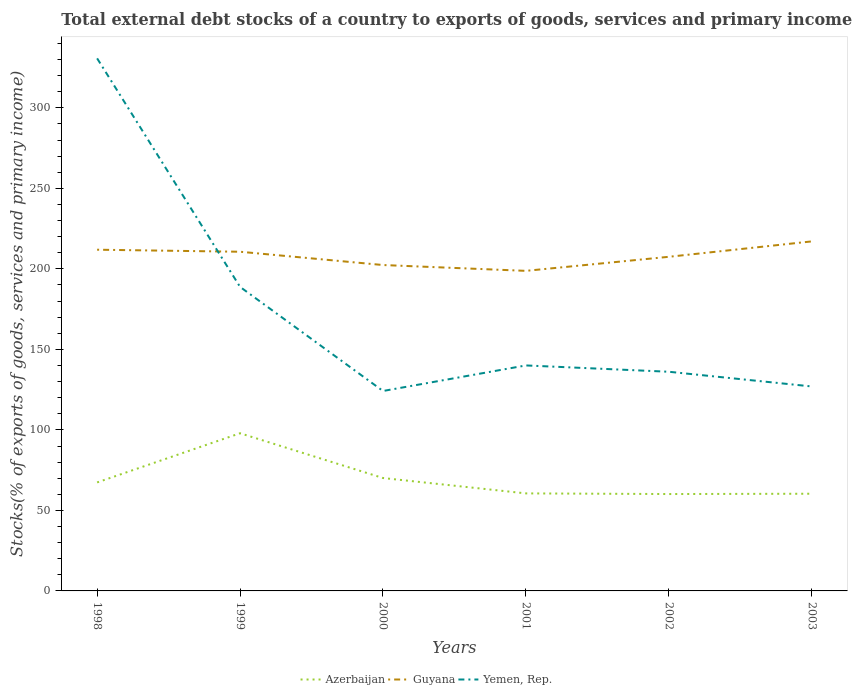Does the line corresponding to Yemen, Rep. intersect with the line corresponding to Guyana?
Keep it short and to the point. Yes. Is the number of lines equal to the number of legend labels?
Provide a succinct answer. Yes. Across all years, what is the maximum total debt stocks in Guyana?
Make the answer very short. 198.77. In which year was the total debt stocks in Azerbaijan maximum?
Your answer should be compact. 2002. What is the total total debt stocks in Yemen, Rep. in the graph?
Give a very brief answer. 194.63. What is the difference between the highest and the second highest total debt stocks in Yemen, Rep.?
Offer a terse response. 206.57. Is the total debt stocks in Guyana strictly greater than the total debt stocks in Yemen, Rep. over the years?
Provide a short and direct response. No. How many lines are there?
Provide a succinct answer. 3. Are the values on the major ticks of Y-axis written in scientific E-notation?
Your answer should be very brief. No. Where does the legend appear in the graph?
Ensure brevity in your answer.  Bottom center. How many legend labels are there?
Ensure brevity in your answer.  3. How are the legend labels stacked?
Your response must be concise. Horizontal. What is the title of the graph?
Offer a very short reply. Total external debt stocks of a country to exports of goods, services and primary income. What is the label or title of the Y-axis?
Give a very brief answer. Stocks(% of exports of goods, services and primary income). What is the Stocks(% of exports of goods, services and primary income) in Azerbaijan in 1998?
Give a very brief answer. 67.38. What is the Stocks(% of exports of goods, services and primary income) in Guyana in 1998?
Provide a succinct answer. 211.9. What is the Stocks(% of exports of goods, services and primary income) in Yemen, Rep. in 1998?
Make the answer very short. 330.74. What is the Stocks(% of exports of goods, services and primary income) in Azerbaijan in 1999?
Give a very brief answer. 97.92. What is the Stocks(% of exports of goods, services and primary income) of Guyana in 1999?
Offer a very short reply. 210.64. What is the Stocks(% of exports of goods, services and primary income) of Yemen, Rep. in 1999?
Ensure brevity in your answer.  188.81. What is the Stocks(% of exports of goods, services and primary income) in Azerbaijan in 2000?
Ensure brevity in your answer.  70.11. What is the Stocks(% of exports of goods, services and primary income) in Guyana in 2000?
Your answer should be compact. 202.39. What is the Stocks(% of exports of goods, services and primary income) in Yemen, Rep. in 2000?
Make the answer very short. 124.16. What is the Stocks(% of exports of goods, services and primary income) in Azerbaijan in 2001?
Your response must be concise. 60.57. What is the Stocks(% of exports of goods, services and primary income) in Guyana in 2001?
Offer a terse response. 198.77. What is the Stocks(% of exports of goods, services and primary income) in Yemen, Rep. in 2001?
Offer a very short reply. 140.04. What is the Stocks(% of exports of goods, services and primary income) of Azerbaijan in 2002?
Keep it short and to the point. 60.16. What is the Stocks(% of exports of goods, services and primary income) in Guyana in 2002?
Your answer should be compact. 207.5. What is the Stocks(% of exports of goods, services and primary income) of Yemen, Rep. in 2002?
Your answer should be compact. 136.11. What is the Stocks(% of exports of goods, services and primary income) of Azerbaijan in 2003?
Your answer should be very brief. 60.36. What is the Stocks(% of exports of goods, services and primary income) of Guyana in 2003?
Offer a very short reply. 217.07. What is the Stocks(% of exports of goods, services and primary income) of Yemen, Rep. in 2003?
Keep it short and to the point. 126.97. Across all years, what is the maximum Stocks(% of exports of goods, services and primary income) of Azerbaijan?
Give a very brief answer. 97.92. Across all years, what is the maximum Stocks(% of exports of goods, services and primary income) in Guyana?
Make the answer very short. 217.07. Across all years, what is the maximum Stocks(% of exports of goods, services and primary income) of Yemen, Rep.?
Provide a succinct answer. 330.74. Across all years, what is the minimum Stocks(% of exports of goods, services and primary income) of Azerbaijan?
Ensure brevity in your answer.  60.16. Across all years, what is the minimum Stocks(% of exports of goods, services and primary income) in Guyana?
Give a very brief answer. 198.77. Across all years, what is the minimum Stocks(% of exports of goods, services and primary income) of Yemen, Rep.?
Your response must be concise. 124.16. What is the total Stocks(% of exports of goods, services and primary income) of Azerbaijan in the graph?
Keep it short and to the point. 416.51. What is the total Stocks(% of exports of goods, services and primary income) in Guyana in the graph?
Offer a very short reply. 1248.27. What is the total Stocks(% of exports of goods, services and primary income) in Yemen, Rep. in the graph?
Offer a very short reply. 1046.83. What is the difference between the Stocks(% of exports of goods, services and primary income) of Azerbaijan in 1998 and that in 1999?
Your response must be concise. -30.53. What is the difference between the Stocks(% of exports of goods, services and primary income) of Guyana in 1998 and that in 1999?
Offer a very short reply. 1.26. What is the difference between the Stocks(% of exports of goods, services and primary income) of Yemen, Rep. in 1998 and that in 1999?
Your response must be concise. 141.92. What is the difference between the Stocks(% of exports of goods, services and primary income) of Azerbaijan in 1998 and that in 2000?
Provide a succinct answer. -2.73. What is the difference between the Stocks(% of exports of goods, services and primary income) in Guyana in 1998 and that in 2000?
Your answer should be compact. 9.51. What is the difference between the Stocks(% of exports of goods, services and primary income) of Yemen, Rep. in 1998 and that in 2000?
Your answer should be compact. 206.57. What is the difference between the Stocks(% of exports of goods, services and primary income) of Azerbaijan in 1998 and that in 2001?
Offer a very short reply. 6.81. What is the difference between the Stocks(% of exports of goods, services and primary income) of Guyana in 1998 and that in 2001?
Offer a terse response. 13.13. What is the difference between the Stocks(% of exports of goods, services and primary income) of Yemen, Rep. in 1998 and that in 2001?
Keep it short and to the point. 190.7. What is the difference between the Stocks(% of exports of goods, services and primary income) of Azerbaijan in 1998 and that in 2002?
Your response must be concise. 7.22. What is the difference between the Stocks(% of exports of goods, services and primary income) in Guyana in 1998 and that in 2002?
Your answer should be very brief. 4.4. What is the difference between the Stocks(% of exports of goods, services and primary income) of Yemen, Rep. in 1998 and that in 2002?
Your response must be concise. 194.63. What is the difference between the Stocks(% of exports of goods, services and primary income) in Azerbaijan in 1998 and that in 2003?
Offer a terse response. 7.02. What is the difference between the Stocks(% of exports of goods, services and primary income) in Guyana in 1998 and that in 2003?
Provide a succinct answer. -5.17. What is the difference between the Stocks(% of exports of goods, services and primary income) in Yemen, Rep. in 1998 and that in 2003?
Make the answer very short. 203.76. What is the difference between the Stocks(% of exports of goods, services and primary income) in Azerbaijan in 1999 and that in 2000?
Provide a succinct answer. 27.8. What is the difference between the Stocks(% of exports of goods, services and primary income) in Guyana in 1999 and that in 2000?
Offer a terse response. 8.25. What is the difference between the Stocks(% of exports of goods, services and primary income) of Yemen, Rep. in 1999 and that in 2000?
Provide a succinct answer. 64.65. What is the difference between the Stocks(% of exports of goods, services and primary income) of Azerbaijan in 1999 and that in 2001?
Offer a very short reply. 37.35. What is the difference between the Stocks(% of exports of goods, services and primary income) in Guyana in 1999 and that in 2001?
Your answer should be compact. 11.87. What is the difference between the Stocks(% of exports of goods, services and primary income) in Yemen, Rep. in 1999 and that in 2001?
Make the answer very short. 48.77. What is the difference between the Stocks(% of exports of goods, services and primary income) in Azerbaijan in 1999 and that in 2002?
Ensure brevity in your answer.  37.75. What is the difference between the Stocks(% of exports of goods, services and primary income) of Guyana in 1999 and that in 2002?
Make the answer very short. 3.14. What is the difference between the Stocks(% of exports of goods, services and primary income) of Yemen, Rep. in 1999 and that in 2002?
Ensure brevity in your answer.  52.7. What is the difference between the Stocks(% of exports of goods, services and primary income) of Azerbaijan in 1999 and that in 2003?
Your response must be concise. 37.56. What is the difference between the Stocks(% of exports of goods, services and primary income) of Guyana in 1999 and that in 2003?
Your answer should be compact. -6.43. What is the difference between the Stocks(% of exports of goods, services and primary income) of Yemen, Rep. in 1999 and that in 2003?
Provide a succinct answer. 61.84. What is the difference between the Stocks(% of exports of goods, services and primary income) of Azerbaijan in 2000 and that in 2001?
Make the answer very short. 9.54. What is the difference between the Stocks(% of exports of goods, services and primary income) of Guyana in 2000 and that in 2001?
Your answer should be very brief. 3.62. What is the difference between the Stocks(% of exports of goods, services and primary income) in Yemen, Rep. in 2000 and that in 2001?
Your answer should be very brief. -15.87. What is the difference between the Stocks(% of exports of goods, services and primary income) of Azerbaijan in 2000 and that in 2002?
Provide a short and direct response. 9.95. What is the difference between the Stocks(% of exports of goods, services and primary income) in Guyana in 2000 and that in 2002?
Your response must be concise. -5.11. What is the difference between the Stocks(% of exports of goods, services and primary income) in Yemen, Rep. in 2000 and that in 2002?
Your response must be concise. -11.94. What is the difference between the Stocks(% of exports of goods, services and primary income) in Azerbaijan in 2000 and that in 2003?
Give a very brief answer. 9.75. What is the difference between the Stocks(% of exports of goods, services and primary income) in Guyana in 2000 and that in 2003?
Offer a terse response. -14.68. What is the difference between the Stocks(% of exports of goods, services and primary income) of Yemen, Rep. in 2000 and that in 2003?
Ensure brevity in your answer.  -2.81. What is the difference between the Stocks(% of exports of goods, services and primary income) in Azerbaijan in 2001 and that in 2002?
Offer a very short reply. 0.4. What is the difference between the Stocks(% of exports of goods, services and primary income) of Guyana in 2001 and that in 2002?
Keep it short and to the point. -8.73. What is the difference between the Stocks(% of exports of goods, services and primary income) in Yemen, Rep. in 2001 and that in 2002?
Your response must be concise. 3.93. What is the difference between the Stocks(% of exports of goods, services and primary income) in Azerbaijan in 2001 and that in 2003?
Your answer should be compact. 0.21. What is the difference between the Stocks(% of exports of goods, services and primary income) in Guyana in 2001 and that in 2003?
Keep it short and to the point. -18.3. What is the difference between the Stocks(% of exports of goods, services and primary income) in Yemen, Rep. in 2001 and that in 2003?
Your answer should be compact. 13.06. What is the difference between the Stocks(% of exports of goods, services and primary income) of Azerbaijan in 2002 and that in 2003?
Provide a short and direct response. -0.19. What is the difference between the Stocks(% of exports of goods, services and primary income) in Guyana in 2002 and that in 2003?
Keep it short and to the point. -9.57. What is the difference between the Stocks(% of exports of goods, services and primary income) of Yemen, Rep. in 2002 and that in 2003?
Make the answer very short. 9.13. What is the difference between the Stocks(% of exports of goods, services and primary income) in Azerbaijan in 1998 and the Stocks(% of exports of goods, services and primary income) in Guyana in 1999?
Your response must be concise. -143.26. What is the difference between the Stocks(% of exports of goods, services and primary income) in Azerbaijan in 1998 and the Stocks(% of exports of goods, services and primary income) in Yemen, Rep. in 1999?
Your answer should be very brief. -121.43. What is the difference between the Stocks(% of exports of goods, services and primary income) in Guyana in 1998 and the Stocks(% of exports of goods, services and primary income) in Yemen, Rep. in 1999?
Your response must be concise. 23.09. What is the difference between the Stocks(% of exports of goods, services and primary income) in Azerbaijan in 1998 and the Stocks(% of exports of goods, services and primary income) in Guyana in 2000?
Ensure brevity in your answer.  -135.01. What is the difference between the Stocks(% of exports of goods, services and primary income) of Azerbaijan in 1998 and the Stocks(% of exports of goods, services and primary income) of Yemen, Rep. in 2000?
Your response must be concise. -56.78. What is the difference between the Stocks(% of exports of goods, services and primary income) of Guyana in 1998 and the Stocks(% of exports of goods, services and primary income) of Yemen, Rep. in 2000?
Give a very brief answer. 87.74. What is the difference between the Stocks(% of exports of goods, services and primary income) in Azerbaijan in 1998 and the Stocks(% of exports of goods, services and primary income) in Guyana in 2001?
Give a very brief answer. -131.39. What is the difference between the Stocks(% of exports of goods, services and primary income) in Azerbaijan in 1998 and the Stocks(% of exports of goods, services and primary income) in Yemen, Rep. in 2001?
Ensure brevity in your answer.  -72.65. What is the difference between the Stocks(% of exports of goods, services and primary income) of Guyana in 1998 and the Stocks(% of exports of goods, services and primary income) of Yemen, Rep. in 2001?
Your answer should be very brief. 71.86. What is the difference between the Stocks(% of exports of goods, services and primary income) in Azerbaijan in 1998 and the Stocks(% of exports of goods, services and primary income) in Guyana in 2002?
Offer a very short reply. -140.12. What is the difference between the Stocks(% of exports of goods, services and primary income) in Azerbaijan in 1998 and the Stocks(% of exports of goods, services and primary income) in Yemen, Rep. in 2002?
Make the answer very short. -68.72. What is the difference between the Stocks(% of exports of goods, services and primary income) in Guyana in 1998 and the Stocks(% of exports of goods, services and primary income) in Yemen, Rep. in 2002?
Your response must be concise. 75.79. What is the difference between the Stocks(% of exports of goods, services and primary income) of Azerbaijan in 1998 and the Stocks(% of exports of goods, services and primary income) of Guyana in 2003?
Provide a succinct answer. -149.69. What is the difference between the Stocks(% of exports of goods, services and primary income) in Azerbaijan in 1998 and the Stocks(% of exports of goods, services and primary income) in Yemen, Rep. in 2003?
Offer a very short reply. -59.59. What is the difference between the Stocks(% of exports of goods, services and primary income) of Guyana in 1998 and the Stocks(% of exports of goods, services and primary income) of Yemen, Rep. in 2003?
Keep it short and to the point. 84.93. What is the difference between the Stocks(% of exports of goods, services and primary income) in Azerbaijan in 1999 and the Stocks(% of exports of goods, services and primary income) in Guyana in 2000?
Your response must be concise. -104.47. What is the difference between the Stocks(% of exports of goods, services and primary income) in Azerbaijan in 1999 and the Stocks(% of exports of goods, services and primary income) in Yemen, Rep. in 2000?
Offer a terse response. -26.25. What is the difference between the Stocks(% of exports of goods, services and primary income) in Guyana in 1999 and the Stocks(% of exports of goods, services and primary income) in Yemen, Rep. in 2000?
Offer a very short reply. 86.48. What is the difference between the Stocks(% of exports of goods, services and primary income) in Azerbaijan in 1999 and the Stocks(% of exports of goods, services and primary income) in Guyana in 2001?
Offer a very short reply. -100.85. What is the difference between the Stocks(% of exports of goods, services and primary income) of Azerbaijan in 1999 and the Stocks(% of exports of goods, services and primary income) of Yemen, Rep. in 2001?
Provide a succinct answer. -42.12. What is the difference between the Stocks(% of exports of goods, services and primary income) in Guyana in 1999 and the Stocks(% of exports of goods, services and primary income) in Yemen, Rep. in 2001?
Provide a short and direct response. 70.6. What is the difference between the Stocks(% of exports of goods, services and primary income) in Azerbaijan in 1999 and the Stocks(% of exports of goods, services and primary income) in Guyana in 2002?
Make the answer very short. -109.58. What is the difference between the Stocks(% of exports of goods, services and primary income) of Azerbaijan in 1999 and the Stocks(% of exports of goods, services and primary income) of Yemen, Rep. in 2002?
Offer a terse response. -38.19. What is the difference between the Stocks(% of exports of goods, services and primary income) of Guyana in 1999 and the Stocks(% of exports of goods, services and primary income) of Yemen, Rep. in 2002?
Make the answer very short. 74.53. What is the difference between the Stocks(% of exports of goods, services and primary income) in Azerbaijan in 1999 and the Stocks(% of exports of goods, services and primary income) in Guyana in 2003?
Provide a short and direct response. -119.15. What is the difference between the Stocks(% of exports of goods, services and primary income) of Azerbaijan in 1999 and the Stocks(% of exports of goods, services and primary income) of Yemen, Rep. in 2003?
Ensure brevity in your answer.  -29.06. What is the difference between the Stocks(% of exports of goods, services and primary income) in Guyana in 1999 and the Stocks(% of exports of goods, services and primary income) in Yemen, Rep. in 2003?
Your answer should be compact. 83.67. What is the difference between the Stocks(% of exports of goods, services and primary income) of Azerbaijan in 2000 and the Stocks(% of exports of goods, services and primary income) of Guyana in 2001?
Keep it short and to the point. -128.66. What is the difference between the Stocks(% of exports of goods, services and primary income) of Azerbaijan in 2000 and the Stocks(% of exports of goods, services and primary income) of Yemen, Rep. in 2001?
Keep it short and to the point. -69.92. What is the difference between the Stocks(% of exports of goods, services and primary income) in Guyana in 2000 and the Stocks(% of exports of goods, services and primary income) in Yemen, Rep. in 2001?
Ensure brevity in your answer.  62.35. What is the difference between the Stocks(% of exports of goods, services and primary income) of Azerbaijan in 2000 and the Stocks(% of exports of goods, services and primary income) of Guyana in 2002?
Give a very brief answer. -137.39. What is the difference between the Stocks(% of exports of goods, services and primary income) of Azerbaijan in 2000 and the Stocks(% of exports of goods, services and primary income) of Yemen, Rep. in 2002?
Your answer should be very brief. -65.99. What is the difference between the Stocks(% of exports of goods, services and primary income) of Guyana in 2000 and the Stocks(% of exports of goods, services and primary income) of Yemen, Rep. in 2002?
Your response must be concise. 66.28. What is the difference between the Stocks(% of exports of goods, services and primary income) of Azerbaijan in 2000 and the Stocks(% of exports of goods, services and primary income) of Guyana in 2003?
Ensure brevity in your answer.  -146.96. What is the difference between the Stocks(% of exports of goods, services and primary income) in Azerbaijan in 2000 and the Stocks(% of exports of goods, services and primary income) in Yemen, Rep. in 2003?
Keep it short and to the point. -56.86. What is the difference between the Stocks(% of exports of goods, services and primary income) in Guyana in 2000 and the Stocks(% of exports of goods, services and primary income) in Yemen, Rep. in 2003?
Make the answer very short. 75.42. What is the difference between the Stocks(% of exports of goods, services and primary income) of Azerbaijan in 2001 and the Stocks(% of exports of goods, services and primary income) of Guyana in 2002?
Your response must be concise. -146.93. What is the difference between the Stocks(% of exports of goods, services and primary income) in Azerbaijan in 2001 and the Stocks(% of exports of goods, services and primary income) in Yemen, Rep. in 2002?
Give a very brief answer. -75.54. What is the difference between the Stocks(% of exports of goods, services and primary income) of Guyana in 2001 and the Stocks(% of exports of goods, services and primary income) of Yemen, Rep. in 2002?
Ensure brevity in your answer.  62.66. What is the difference between the Stocks(% of exports of goods, services and primary income) of Azerbaijan in 2001 and the Stocks(% of exports of goods, services and primary income) of Guyana in 2003?
Keep it short and to the point. -156.5. What is the difference between the Stocks(% of exports of goods, services and primary income) in Azerbaijan in 2001 and the Stocks(% of exports of goods, services and primary income) in Yemen, Rep. in 2003?
Your answer should be very brief. -66.41. What is the difference between the Stocks(% of exports of goods, services and primary income) in Guyana in 2001 and the Stocks(% of exports of goods, services and primary income) in Yemen, Rep. in 2003?
Your answer should be very brief. 71.8. What is the difference between the Stocks(% of exports of goods, services and primary income) of Azerbaijan in 2002 and the Stocks(% of exports of goods, services and primary income) of Guyana in 2003?
Provide a succinct answer. -156.9. What is the difference between the Stocks(% of exports of goods, services and primary income) of Azerbaijan in 2002 and the Stocks(% of exports of goods, services and primary income) of Yemen, Rep. in 2003?
Offer a very short reply. -66.81. What is the difference between the Stocks(% of exports of goods, services and primary income) in Guyana in 2002 and the Stocks(% of exports of goods, services and primary income) in Yemen, Rep. in 2003?
Keep it short and to the point. 80.52. What is the average Stocks(% of exports of goods, services and primary income) of Azerbaijan per year?
Give a very brief answer. 69.42. What is the average Stocks(% of exports of goods, services and primary income) of Guyana per year?
Your response must be concise. 208.05. What is the average Stocks(% of exports of goods, services and primary income) of Yemen, Rep. per year?
Offer a terse response. 174.47. In the year 1998, what is the difference between the Stocks(% of exports of goods, services and primary income) of Azerbaijan and Stocks(% of exports of goods, services and primary income) of Guyana?
Provide a short and direct response. -144.52. In the year 1998, what is the difference between the Stocks(% of exports of goods, services and primary income) in Azerbaijan and Stocks(% of exports of goods, services and primary income) in Yemen, Rep.?
Offer a terse response. -263.35. In the year 1998, what is the difference between the Stocks(% of exports of goods, services and primary income) of Guyana and Stocks(% of exports of goods, services and primary income) of Yemen, Rep.?
Make the answer very short. -118.83. In the year 1999, what is the difference between the Stocks(% of exports of goods, services and primary income) in Azerbaijan and Stocks(% of exports of goods, services and primary income) in Guyana?
Offer a very short reply. -112.73. In the year 1999, what is the difference between the Stocks(% of exports of goods, services and primary income) of Azerbaijan and Stocks(% of exports of goods, services and primary income) of Yemen, Rep.?
Offer a terse response. -90.9. In the year 1999, what is the difference between the Stocks(% of exports of goods, services and primary income) of Guyana and Stocks(% of exports of goods, services and primary income) of Yemen, Rep.?
Give a very brief answer. 21.83. In the year 2000, what is the difference between the Stocks(% of exports of goods, services and primary income) of Azerbaijan and Stocks(% of exports of goods, services and primary income) of Guyana?
Provide a succinct answer. -132.28. In the year 2000, what is the difference between the Stocks(% of exports of goods, services and primary income) in Azerbaijan and Stocks(% of exports of goods, services and primary income) in Yemen, Rep.?
Provide a succinct answer. -54.05. In the year 2000, what is the difference between the Stocks(% of exports of goods, services and primary income) of Guyana and Stocks(% of exports of goods, services and primary income) of Yemen, Rep.?
Your response must be concise. 78.23. In the year 2001, what is the difference between the Stocks(% of exports of goods, services and primary income) of Azerbaijan and Stocks(% of exports of goods, services and primary income) of Guyana?
Your answer should be compact. -138.2. In the year 2001, what is the difference between the Stocks(% of exports of goods, services and primary income) in Azerbaijan and Stocks(% of exports of goods, services and primary income) in Yemen, Rep.?
Your answer should be very brief. -79.47. In the year 2001, what is the difference between the Stocks(% of exports of goods, services and primary income) in Guyana and Stocks(% of exports of goods, services and primary income) in Yemen, Rep.?
Your answer should be very brief. 58.73. In the year 2002, what is the difference between the Stocks(% of exports of goods, services and primary income) in Azerbaijan and Stocks(% of exports of goods, services and primary income) in Guyana?
Ensure brevity in your answer.  -147.33. In the year 2002, what is the difference between the Stocks(% of exports of goods, services and primary income) in Azerbaijan and Stocks(% of exports of goods, services and primary income) in Yemen, Rep.?
Offer a very short reply. -75.94. In the year 2002, what is the difference between the Stocks(% of exports of goods, services and primary income) in Guyana and Stocks(% of exports of goods, services and primary income) in Yemen, Rep.?
Ensure brevity in your answer.  71.39. In the year 2003, what is the difference between the Stocks(% of exports of goods, services and primary income) in Azerbaijan and Stocks(% of exports of goods, services and primary income) in Guyana?
Make the answer very short. -156.71. In the year 2003, what is the difference between the Stocks(% of exports of goods, services and primary income) in Azerbaijan and Stocks(% of exports of goods, services and primary income) in Yemen, Rep.?
Make the answer very short. -66.61. In the year 2003, what is the difference between the Stocks(% of exports of goods, services and primary income) of Guyana and Stocks(% of exports of goods, services and primary income) of Yemen, Rep.?
Keep it short and to the point. 90.09. What is the ratio of the Stocks(% of exports of goods, services and primary income) in Azerbaijan in 1998 to that in 1999?
Your response must be concise. 0.69. What is the ratio of the Stocks(% of exports of goods, services and primary income) in Yemen, Rep. in 1998 to that in 1999?
Provide a short and direct response. 1.75. What is the ratio of the Stocks(% of exports of goods, services and primary income) of Azerbaijan in 1998 to that in 2000?
Your answer should be very brief. 0.96. What is the ratio of the Stocks(% of exports of goods, services and primary income) of Guyana in 1998 to that in 2000?
Provide a succinct answer. 1.05. What is the ratio of the Stocks(% of exports of goods, services and primary income) of Yemen, Rep. in 1998 to that in 2000?
Keep it short and to the point. 2.66. What is the ratio of the Stocks(% of exports of goods, services and primary income) of Azerbaijan in 1998 to that in 2001?
Provide a short and direct response. 1.11. What is the ratio of the Stocks(% of exports of goods, services and primary income) in Guyana in 1998 to that in 2001?
Your answer should be very brief. 1.07. What is the ratio of the Stocks(% of exports of goods, services and primary income) of Yemen, Rep. in 1998 to that in 2001?
Give a very brief answer. 2.36. What is the ratio of the Stocks(% of exports of goods, services and primary income) in Azerbaijan in 1998 to that in 2002?
Offer a terse response. 1.12. What is the ratio of the Stocks(% of exports of goods, services and primary income) in Guyana in 1998 to that in 2002?
Ensure brevity in your answer.  1.02. What is the ratio of the Stocks(% of exports of goods, services and primary income) in Yemen, Rep. in 1998 to that in 2002?
Offer a very short reply. 2.43. What is the ratio of the Stocks(% of exports of goods, services and primary income) in Azerbaijan in 1998 to that in 2003?
Offer a terse response. 1.12. What is the ratio of the Stocks(% of exports of goods, services and primary income) in Guyana in 1998 to that in 2003?
Offer a very short reply. 0.98. What is the ratio of the Stocks(% of exports of goods, services and primary income) in Yemen, Rep. in 1998 to that in 2003?
Offer a very short reply. 2.6. What is the ratio of the Stocks(% of exports of goods, services and primary income) in Azerbaijan in 1999 to that in 2000?
Provide a succinct answer. 1.4. What is the ratio of the Stocks(% of exports of goods, services and primary income) of Guyana in 1999 to that in 2000?
Ensure brevity in your answer.  1.04. What is the ratio of the Stocks(% of exports of goods, services and primary income) of Yemen, Rep. in 1999 to that in 2000?
Your response must be concise. 1.52. What is the ratio of the Stocks(% of exports of goods, services and primary income) in Azerbaijan in 1999 to that in 2001?
Your answer should be compact. 1.62. What is the ratio of the Stocks(% of exports of goods, services and primary income) in Guyana in 1999 to that in 2001?
Your response must be concise. 1.06. What is the ratio of the Stocks(% of exports of goods, services and primary income) in Yemen, Rep. in 1999 to that in 2001?
Provide a short and direct response. 1.35. What is the ratio of the Stocks(% of exports of goods, services and primary income) of Azerbaijan in 1999 to that in 2002?
Give a very brief answer. 1.63. What is the ratio of the Stocks(% of exports of goods, services and primary income) of Guyana in 1999 to that in 2002?
Ensure brevity in your answer.  1.02. What is the ratio of the Stocks(% of exports of goods, services and primary income) of Yemen, Rep. in 1999 to that in 2002?
Your response must be concise. 1.39. What is the ratio of the Stocks(% of exports of goods, services and primary income) of Azerbaijan in 1999 to that in 2003?
Provide a succinct answer. 1.62. What is the ratio of the Stocks(% of exports of goods, services and primary income) of Guyana in 1999 to that in 2003?
Keep it short and to the point. 0.97. What is the ratio of the Stocks(% of exports of goods, services and primary income) of Yemen, Rep. in 1999 to that in 2003?
Your response must be concise. 1.49. What is the ratio of the Stocks(% of exports of goods, services and primary income) in Azerbaijan in 2000 to that in 2001?
Offer a terse response. 1.16. What is the ratio of the Stocks(% of exports of goods, services and primary income) in Guyana in 2000 to that in 2001?
Offer a terse response. 1.02. What is the ratio of the Stocks(% of exports of goods, services and primary income) of Yemen, Rep. in 2000 to that in 2001?
Offer a very short reply. 0.89. What is the ratio of the Stocks(% of exports of goods, services and primary income) of Azerbaijan in 2000 to that in 2002?
Your answer should be very brief. 1.17. What is the ratio of the Stocks(% of exports of goods, services and primary income) in Guyana in 2000 to that in 2002?
Ensure brevity in your answer.  0.98. What is the ratio of the Stocks(% of exports of goods, services and primary income) of Yemen, Rep. in 2000 to that in 2002?
Your answer should be very brief. 0.91. What is the ratio of the Stocks(% of exports of goods, services and primary income) in Azerbaijan in 2000 to that in 2003?
Keep it short and to the point. 1.16. What is the ratio of the Stocks(% of exports of goods, services and primary income) of Guyana in 2000 to that in 2003?
Your answer should be very brief. 0.93. What is the ratio of the Stocks(% of exports of goods, services and primary income) of Yemen, Rep. in 2000 to that in 2003?
Make the answer very short. 0.98. What is the ratio of the Stocks(% of exports of goods, services and primary income) in Azerbaijan in 2001 to that in 2002?
Ensure brevity in your answer.  1.01. What is the ratio of the Stocks(% of exports of goods, services and primary income) of Guyana in 2001 to that in 2002?
Ensure brevity in your answer.  0.96. What is the ratio of the Stocks(% of exports of goods, services and primary income) of Yemen, Rep. in 2001 to that in 2002?
Keep it short and to the point. 1.03. What is the ratio of the Stocks(% of exports of goods, services and primary income) of Guyana in 2001 to that in 2003?
Your answer should be compact. 0.92. What is the ratio of the Stocks(% of exports of goods, services and primary income) of Yemen, Rep. in 2001 to that in 2003?
Keep it short and to the point. 1.1. What is the ratio of the Stocks(% of exports of goods, services and primary income) of Azerbaijan in 2002 to that in 2003?
Provide a succinct answer. 1. What is the ratio of the Stocks(% of exports of goods, services and primary income) in Guyana in 2002 to that in 2003?
Ensure brevity in your answer.  0.96. What is the ratio of the Stocks(% of exports of goods, services and primary income) in Yemen, Rep. in 2002 to that in 2003?
Offer a very short reply. 1.07. What is the difference between the highest and the second highest Stocks(% of exports of goods, services and primary income) in Azerbaijan?
Give a very brief answer. 27.8. What is the difference between the highest and the second highest Stocks(% of exports of goods, services and primary income) of Guyana?
Give a very brief answer. 5.17. What is the difference between the highest and the second highest Stocks(% of exports of goods, services and primary income) of Yemen, Rep.?
Your response must be concise. 141.92. What is the difference between the highest and the lowest Stocks(% of exports of goods, services and primary income) of Azerbaijan?
Offer a terse response. 37.75. What is the difference between the highest and the lowest Stocks(% of exports of goods, services and primary income) in Guyana?
Provide a succinct answer. 18.3. What is the difference between the highest and the lowest Stocks(% of exports of goods, services and primary income) in Yemen, Rep.?
Make the answer very short. 206.57. 